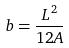Convert formula to latex. <formula><loc_0><loc_0><loc_500><loc_500>b = \frac { L ^ { 2 } } { 1 2 A }</formula> 